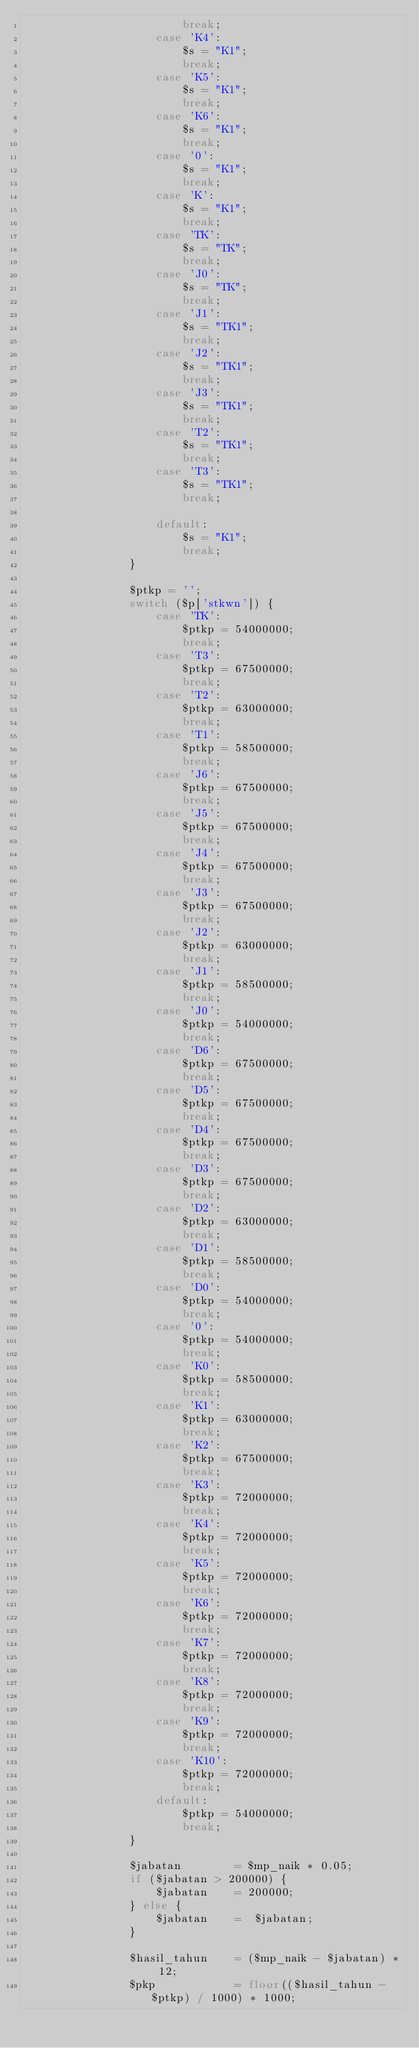<code> <loc_0><loc_0><loc_500><loc_500><_PHP_>                        break;
                    case 'K4':
                        $s = "K1";
                        break;
                    case 'K5':
                        $s = "K1";
                        break;
                    case 'K6':
                        $s = "K1";
                        break;
                    case '0':
                        $s = "K1";
                        break;
                    case 'K':
                        $s = "K1";
                        break;
                    case 'TK':
                        $s = "TK";
                        break;
                    case 'J0':
                        $s = "TK";
                        break;
                    case 'J1':
                        $s = "TK1";
                        break;
                    case 'J2':
                        $s = "TK1";
                        break;
                    case 'J3':
                        $s = "TK1";
                        break;
                    case 'T2':
                        $s = "TK1";
                        break;
                    case 'T3':
                        $s = "TK1";
                        break;

                    default:
                        $s = "K1";
                        break;
                }

                $ptkp = '';
                switch ($p['stkwn']) {
                    case 'TK':
                        $ptkp = 54000000;
                        break;
                    case 'T3':
                        $ptkp = 67500000;
                        break;
                    case 'T2':
                        $ptkp = 63000000;
                        break;
                    case 'T1':
                        $ptkp = 58500000;
                        break;
                    case 'J6':
                        $ptkp = 67500000;
                        break;
                    case 'J5':
                        $ptkp = 67500000;
                        break;
                    case 'J4':
                        $ptkp = 67500000;
                        break;
                    case 'J3':
                        $ptkp = 67500000;
                        break;
                    case 'J2':
                        $ptkp = 63000000;
                        break;
                    case 'J1':
                        $ptkp = 58500000;
                        break;
                    case 'J0':
                        $ptkp = 54000000;
                        break;
                    case 'D6':
                        $ptkp = 67500000;
                        break;
                    case 'D5':
                        $ptkp = 67500000;
                        break;
                    case 'D4':
                        $ptkp = 67500000;
                        break;
                    case 'D3':
                        $ptkp = 67500000;
                        break;
                    case 'D2':
                        $ptkp = 63000000;
                        break;
                    case 'D1':
                        $ptkp = 58500000;
                        break;
                    case 'D0':
                        $ptkp = 54000000;
                        break;
                    case '0':
                        $ptkp = 54000000;
                        break;
                    case 'K0':
                        $ptkp = 58500000;
                        break;
                    case 'K1':
                        $ptkp = 63000000;
                        break;
                    case 'K2':
                        $ptkp = 67500000;
                        break;
                    case 'K3':
                        $ptkp = 72000000;
                        break;
                    case 'K4':
                        $ptkp = 72000000;
                        break;
                    case 'K5':
                        $ptkp = 72000000;
                        break;
                    case 'K6':
                        $ptkp = 72000000;
                        break;
                    case 'K7':
                        $ptkp = 72000000;
                        break;
                    case 'K8':
                        $ptkp = 72000000;
                        break;
                    case 'K9':
                        $ptkp = 72000000;
                        break;
                    case 'K10':
                        $ptkp = 72000000;
                        break;
                    default:
                        $ptkp = 54000000;
                        break;
                }

                $jabatan        = $mp_naik * 0.05;
                if ($jabatan > 200000) {
                    $jabatan    = 200000;
                } else {
                    $jabatan    =  $jabatan;
                }

                $hasil_tahun    = ($mp_naik - $jabatan) * 12;
                $pkp            = floor(($hasil_tahun - $ptkp) / 1000) * 1000;
</code> 